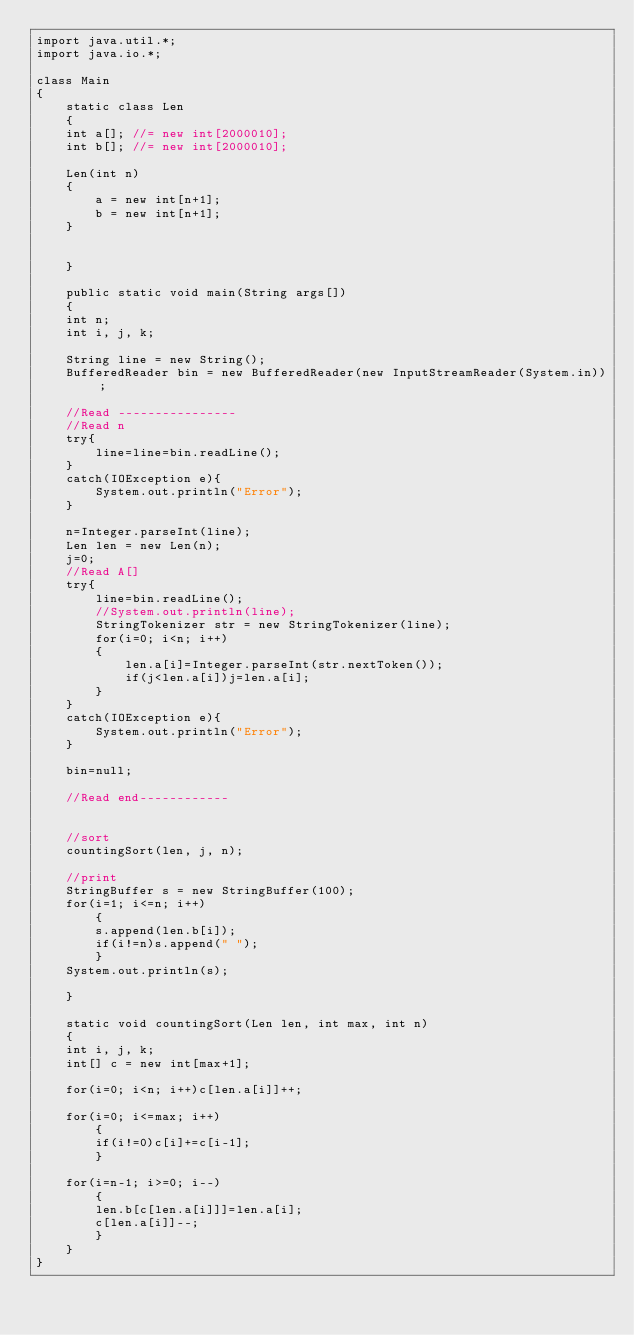Convert code to text. <code><loc_0><loc_0><loc_500><loc_500><_Java_>import java.util.*;
import java.io.*;

class Main
{
    static class Len
    {	
	int a[]; //= new int[2000010];
	int b[]; //= new int[2000010];
	
	Len(int n)
	{
	    a = new int[n+1];
	    b = new int[n+1];
	}
	

    }

    public static void main(String args[])
    {
	int n;
	int i, j, k;

	String line = new String();
	BufferedReader bin = new BufferedReader(new InputStreamReader(System.in));

	//Read ----------------
	//Read n
	try{
	    line=line=bin.readLine();
	}	
	catch(IOException e){
	    System.out.println("Error");
	}

	n=Integer.parseInt(line);
	Len len = new Len(n);
	j=0;
	//Read A[]
	try{
	    line=bin.readLine();
	    //System.out.println(line);
	    StringTokenizer str = new StringTokenizer(line);   
	    for(i=0; i<n; i++)
		{
		    len.a[i]=Integer.parseInt(str.nextToken());
		    if(j<len.a[i])j=len.a[i];
		}
	}
	catch(IOException e){
	    System.out.println("Error");
	}

	bin=null;

	//Read end------------


	//sort
	countingSort(len, j, n);

	//print
	StringBuffer s = new StringBuffer(100);
	for(i=1; i<=n; i++)
	    {
		s.append(len.b[i]);
		if(i!=n)s.append(" ");
	    }
	System.out.println(s);

    }

    static void countingSort(Len len, int max, int n)
    {
	int i, j, k;
	int[] c = new int[max+1];

	for(i=0; i<n; i++)c[len.a[i]]++;

	for(i=0; i<=max; i++)
	    {
		if(i!=0)c[i]+=c[i-1];
	    }

	for(i=n-1; i>=0; i--)
	    {
		len.b[c[len.a[i]]]=len.a[i];
		c[len.a[i]]--;
	    }
    }
}</code> 